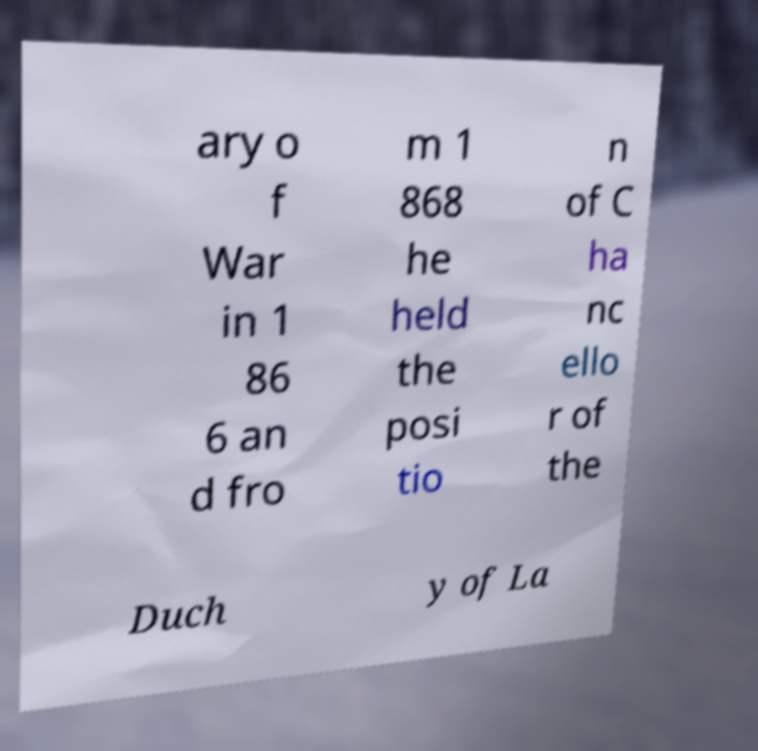Please identify and transcribe the text found in this image. ary o f War in 1 86 6 an d fro m 1 868 he held the posi tio n of C ha nc ello r of the Duch y of La 